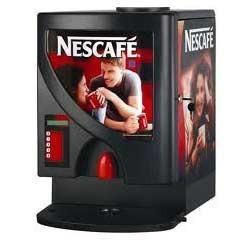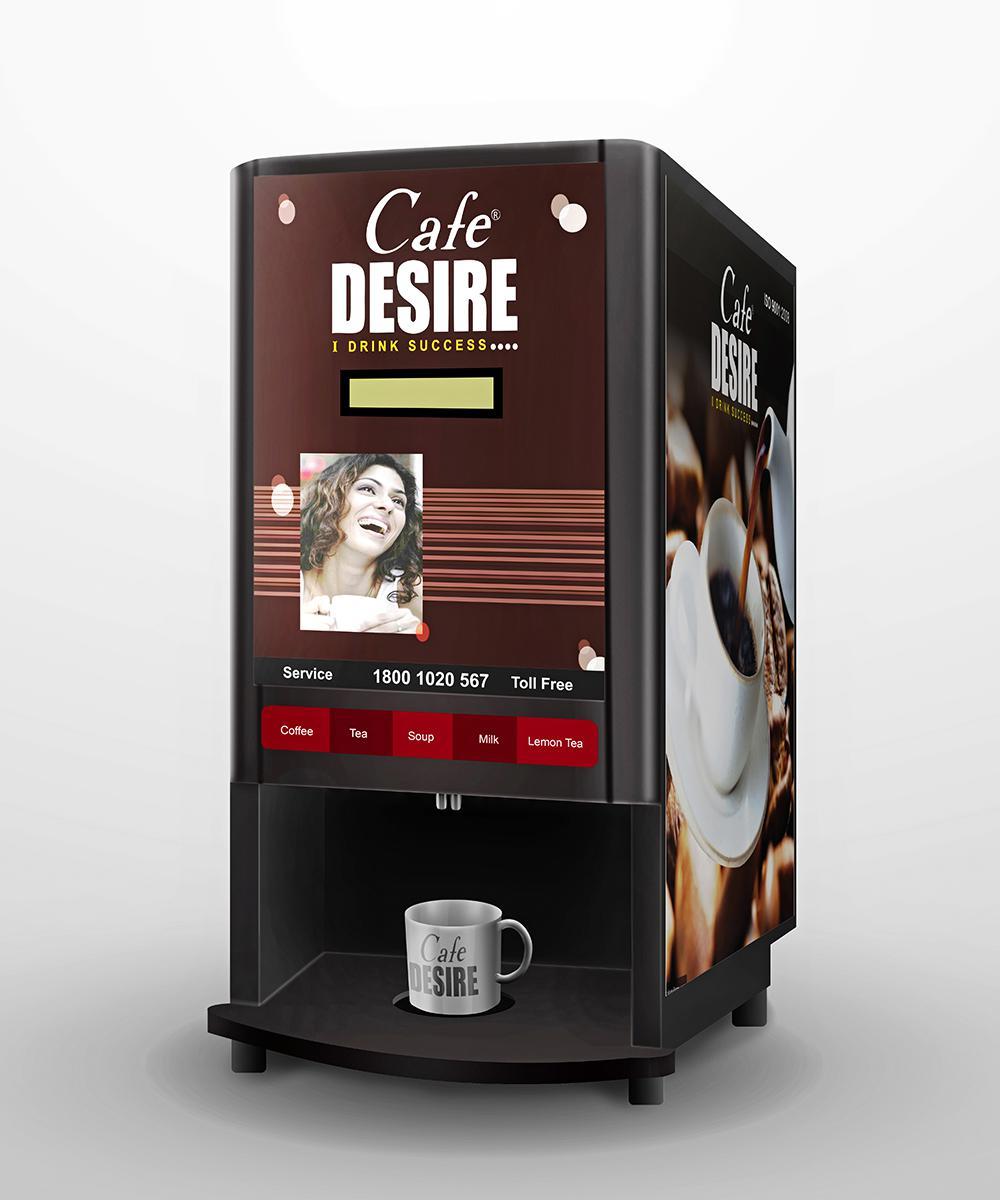The first image is the image on the left, the second image is the image on the right. Evaluate the accuracy of this statement regarding the images: "In one image the coffee maker is open.". Is it true? Answer yes or no. No. 